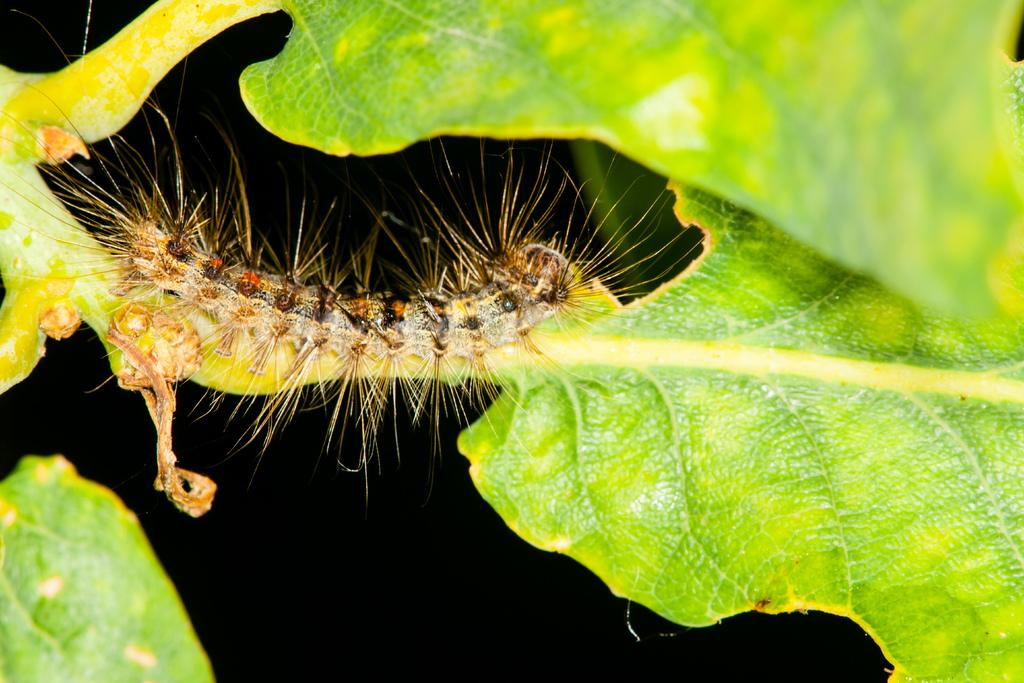What is the main subject of the image? The main subject of the image is a caterpillar. Where is the caterpillar located? The caterpillar is on a part of a plant. What can be observed about the background of the image? The background of the caterpillar is dark. What type of lift can be seen in the image? There is no lift present in the image; it features a caterpillar on a plant. How many railway tracks are visible in the image? There are no railway tracks present in the image. 